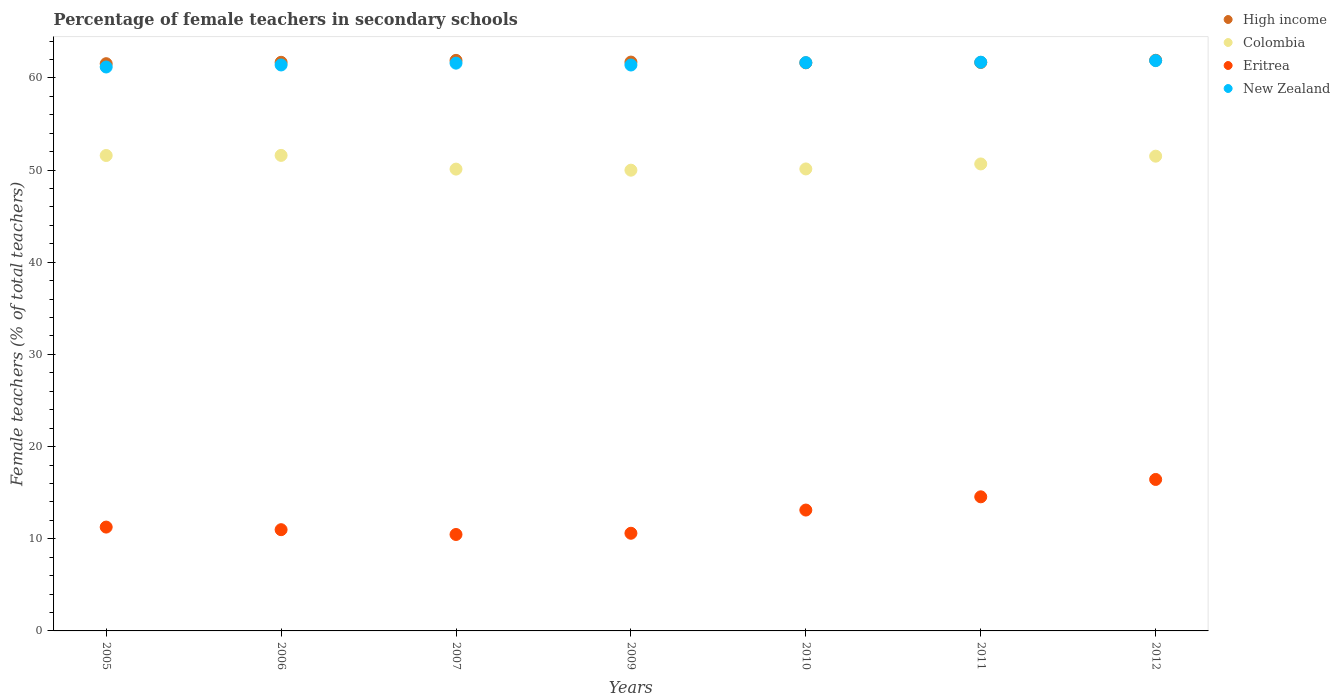How many different coloured dotlines are there?
Keep it short and to the point. 4. What is the percentage of female teachers in High income in 2005?
Give a very brief answer. 61.54. Across all years, what is the maximum percentage of female teachers in Eritrea?
Provide a short and direct response. 16.43. Across all years, what is the minimum percentage of female teachers in Eritrea?
Make the answer very short. 10.46. In which year was the percentage of female teachers in Colombia minimum?
Ensure brevity in your answer.  2009. What is the total percentage of female teachers in High income in the graph?
Offer a terse response. 432.08. What is the difference between the percentage of female teachers in Eritrea in 2009 and that in 2011?
Provide a short and direct response. -3.95. What is the difference between the percentage of female teachers in Eritrea in 2005 and the percentage of female teachers in New Zealand in 2007?
Your answer should be compact. -50.33. What is the average percentage of female teachers in High income per year?
Provide a short and direct response. 61.73. In the year 2009, what is the difference between the percentage of female teachers in Colombia and percentage of female teachers in Eritrea?
Ensure brevity in your answer.  39.39. What is the ratio of the percentage of female teachers in High income in 2006 to that in 2009?
Offer a terse response. 1. Is the difference between the percentage of female teachers in Colombia in 2006 and 2012 greater than the difference between the percentage of female teachers in Eritrea in 2006 and 2012?
Offer a very short reply. Yes. What is the difference between the highest and the second highest percentage of female teachers in New Zealand?
Make the answer very short. 0.17. What is the difference between the highest and the lowest percentage of female teachers in New Zealand?
Ensure brevity in your answer.  0.69. In how many years, is the percentage of female teachers in Eritrea greater than the average percentage of female teachers in Eritrea taken over all years?
Ensure brevity in your answer.  3. Is the percentage of female teachers in High income strictly greater than the percentage of female teachers in New Zealand over the years?
Keep it short and to the point. No. Is the percentage of female teachers in Eritrea strictly less than the percentage of female teachers in Colombia over the years?
Provide a succinct answer. Yes. Does the graph contain grids?
Make the answer very short. No. Where does the legend appear in the graph?
Your answer should be very brief. Top right. How are the legend labels stacked?
Ensure brevity in your answer.  Vertical. What is the title of the graph?
Provide a succinct answer. Percentage of female teachers in secondary schools. What is the label or title of the Y-axis?
Give a very brief answer. Female teachers (% of total teachers). What is the Female teachers (% of total teachers) in High income in 2005?
Make the answer very short. 61.54. What is the Female teachers (% of total teachers) of Colombia in 2005?
Provide a succinct answer. 51.58. What is the Female teachers (% of total teachers) in Eritrea in 2005?
Your answer should be compact. 11.27. What is the Female teachers (% of total teachers) in New Zealand in 2005?
Offer a very short reply. 61.18. What is the Female teachers (% of total teachers) in High income in 2006?
Your response must be concise. 61.69. What is the Female teachers (% of total teachers) in Colombia in 2006?
Your answer should be compact. 51.59. What is the Female teachers (% of total teachers) in Eritrea in 2006?
Provide a succinct answer. 10.98. What is the Female teachers (% of total teachers) in New Zealand in 2006?
Offer a very short reply. 61.4. What is the Female teachers (% of total teachers) in High income in 2007?
Make the answer very short. 61.9. What is the Female teachers (% of total teachers) of Colombia in 2007?
Your response must be concise. 50.11. What is the Female teachers (% of total teachers) in Eritrea in 2007?
Your answer should be compact. 10.46. What is the Female teachers (% of total teachers) in New Zealand in 2007?
Give a very brief answer. 61.6. What is the Female teachers (% of total teachers) of High income in 2009?
Keep it short and to the point. 61.72. What is the Female teachers (% of total teachers) in Colombia in 2009?
Offer a very short reply. 49.99. What is the Female teachers (% of total teachers) of Eritrea in 2009?
Offer a terse response. 10.6. What is the Female teachers (% of total teachers) of New Zealand in 2009?
Keep it short and to the point. 61.4. What is the Female teachers (% of total teachers) of High income in 2010?
Offer a terse response. 61.64. What is the Female teachers (% of total teachers) of Colombia in 2010?
Provide a short and direct response. 50.12. What is the Female teachers (% of total teachers) of Eritrea in 2010?
Provide a short and direct response. 13.11. What is the Female teachers (% of total teachers) in New Zealand in 2010?
Offer a terse response. 61.66. What is the Female teachers (% of total teachers) of High income in 2011?
Your response must be concise. 61.67. What is the Female teachers (% of total teachers) in Colombia in 2011?
Your answer should be very brief. 50.66. What is the Female teachers (% of total teachers) in Eritrea in 2011?
Keep it short and to the point. 14.55. What is the Female teachers (% of total teachers) of New Zealand in 2011?
Ensure brevity in your answer.  61.71. What is the Female teachers (% of total teachers) in High income in 2012?
Make the answer very short. 61.91. What is the Female teachers (% of total teachers) in Colombia in 2012?
Give a very brief answer. 51.51. What is the Female teachers (% of total teachers) of Eritrea in 2012?
Provide a short and direct response. 16.43. What is the Female teachers (% of total teachers) in New Zealand in 2012?
Offer a terse response. 61.88. Across all years, what is the maximum Female teachers (% of total teachers) in High income?
Your response must be concise. 61.91. Across all years, what is the maximum Female teachers (% of total teachers) in Colombia?
Make the answer very short. 51.59. Across all years, what is the maximum Female teachers (% of total teachers) in Eritrea?
Keep it short and to the point. 16.43. Across all years, what is the maximum Female teachers (% of total teachers) in New Zealand?
Provide a short and direct response. 61.88. Across all years, what is the minimum Female teachers (% of total teachers) of High income?
Give a very brief answer. 61.54. Across all years, what is the minimum Female teachers (% of total teachers) of Colombia?
Provide a succinct answer. 49.99. Across all years, what is the minimum Female teachers (% of total teachers) of Eritrea?
Give a very brief answer. 10.46. Across all years, what is the minimum Female teachers (% of total teachers) of New Zealand?
Keep it short and to the point. 61.18. What is the total Female teachers (% of total teachers) of High income in the graph?
Keep it short and to the point. 432.08. What is the total Female teachers (% of total teachers) in Colombia in the graph?
Give a very brief answer. 355.57. What is the total Female teachers (% of total teachers) of Eritrea in the graph?
Provide a short and direct response. 87.41. What is the total Female teachers (% of total teachers) of New Zealand in the graph?
Offer a very short reply. 430.83. What is the difference between the Female teachers (% of total teachers) of High income in 2005 and that in 2006?
Your answer should be compact. -0.15. What is the difference between the Female teachers (% of total teachers) in Colombia in 2005 and that in 2006?
Ensure brevity in your answer.  -0.01. What is the difference between the Female teachers (% of total teachers) of Eritrea in 2005 and that in 2006?
Your response must be concise. 0.28. What is the difference between the Female teachers (% of total teachers) of New Zealand in 2005 and that in 2006?
Keep it short and to the point. -0.22. What is the difference between the Female teachers (% of total teachers) in High income in 2005 and that in 2007?
Provide a succinct answer. -0.36. What is the difference between the Female teachers (% of total teachers) of Colombia in 2005 and that in 2007?
Your answer should be very brief. 1.48. What is the difference between the Female teachers (% of total teachers) in Eritrea in 2005 and that in 2007?
Offer a very short reply. 0.8. What is the difference between the Female teachers (% of total teachers) of New Zealand in 2005 and that in 2007?
Your answer should be very brief. -0.42. What is the difference between the Female teachers (% of total teachers) of High income in 2005 and that in 2009?
Make the answer very short. -0.17. What is the difference between the Female teachers (% of total teachers) in Colombia in 2005 and that in 2009?
Provide a short and direct response. 1.59. What is the difference between the Female teachers (% of total teachers) of Eritrea in 2005 and that in 2009?
Give a very brief answer. 0.67. What is the difference between the Female teachers (% of total teachers) in New Zealand in 2005 and that in 2009?
Your answer should be very brief. -0.22. What is the difference between the Female teachers (% of total teachers) of High income in 2005 and that in 2010?
Keep it short and to the point. -0.1. What is the difference between the Female teachers (% of total teachers) in Colombia in 2005 and that in 2010?
Your answer should be compact. 1.46. What is the difference between the Female teachers (% of total teachers) of Eritrea in 2005 and that in 2010?
Give a very brief answer. -1.85. What is the difference between the Female teachers (% of total teachers) of New Zealand in 2005 and that in 2010?
Make the answer very short. -0.47. What is the difference between the Female teachers (% of total teachers) of High income in 2005 and that in 2011?
Your answer should be very brief. -0.13. What is the difference between the Female teachers (% of total teachers) in Colombia in 2005 and that in 2011?
Offer a terse response. 0.92. What is the difference between the Female teachers (% of total teachers) in Eritrea in 2005 and that in 2011?
Provide a succinct answer. -3.28. What is the difference between the Female teachers (% of total teachers) of New Zealand in 2005 and that in 2011?
Your answer should be compact. -0.52. What is the difference between the Female teachers (% of total teachers) in High income in 2005 and that in 2012?
Offer a terse response. -0.37. What is the difference between the Female teachers (% of total teachers) of Colombia in 2005 and that in 2012?
Offer a terse response. 0.07. What is the difference between the Female teachers (% of total teachers) in Eritrea in 2005 and that in 2012?
Offer a terse response. -5.17. What is the difference between the Female teachers (% of total teachers) in New Zealand in 2005 and that in 2012?
Your answer should be compact. -0.69. What is the difference between the Female teachers (% of total teachers) of High income in 2006 and that in 2007?
Keep it short and to the point. -0.21. What is the difference between the Female teachers (% of total teachers) of Colombia in 2006 and that in 2007?
Your response must be concise. 1.49. What is the difference between the Female teachers (% of total teachers) of Eritrea in 2006 and that in 2007?
Your answer should be compact. 0.52. What is the difference between the Female teachers (% of total teachers) of New Zealand in 2006 and that in 2007?
Ensure brevity in your answer.  -0.2. What is the difference between the Female teachers (% of total teachers) of High income in 2006 and that in 2009?
Your answer should be compact. -0.02. What is the difference between the Female teachers (% of total teachers) in Colombia in 2006 and that in 2009?
Keep it short and to the point. 1.6. What is the difference between the Female teachers (% of total teachers) in Eritrea in 2006 and that in 2009?
Provide a short and direct response. 0.39. What is the difference between the Female teachers (% of total teachers) of New Zealand in 2006 and that in 2009?
Provide a succinct answer. 0.01. What is the difference between the Female teachers (% of total teachers) of High income in 2006 and that in 2010?
Make the answer very short. 0.06. What is the difference between the Female teachers (% of total teachers) in Colombia in 2006 and that in 2010?
Provide a short and direct response. 1.47. What is the difference between the Female teachers (% of total teachers) of Eritrea in 2006 and that in 2010?
Your answer should be compact. -2.13. What is the difference between the Female teachers (% of total teachers) of New Zealand in 2006 and that in 2010?
Your response must be concise. -0.25. What is the difference between the Female teachers (% of total teachers) of Colombia in 2006 and that in 2011?
Your answer should be compact. 0.93. What is the difference between the Female teachers (% of total teachers) in Eritrea in 2006 and that in 2011?
Your answer should be very brief. -3.57. What is the difference between the Female teachers (% of total teachers) of New Zealand in 2006 and that in 2011?
Your answer should be compact. -0.3. What is the difference between the Female teachers (% of total teachers) of High income in 2006 and that in 2012?
Make the answer very short. -0.22. What is the difference between the Female teachers (% of total teachers) in Colombia in 2006 and that in 2012?
Provide a succinct answer. 0.08. What is the difference between the Female teachers (% of total teachers) in Eritrea in 2006 and that in 2012?
Your response must be concise. -5.45. What is the difference between the Female teachers (% of total teachers) in New Zealand in 2006 and that in 2012?
Keep it short and to the point. -0.47. What is the difference between the Female teachers (% of total teachers) in High income in 2007 and that in 2009?
Ensure brevity in your answer.  0.19. What is the difference between the Female teachers (% of total teachers) in Colombia in 2007 and that in 2009?
Offer a terse response. 0.12. What is the difference between the Female teachers (% of total teachers) in Eritrea in 2007 and that in 2009?
Keep it short and to the point. -0.13. What is the difference between the Female teachers (% of total teachers) in New Zealand in 2007 and that in 2009?
Your response must be concise. 0.2. What is the difference between the Female teachers (% of total teachers) in High income in 2007 and that in 2010?
Provide a succinct answer. 0.27. What is the difference between the Female teachers (% of total teachers) in Colombia in 2007 and that in 2010?
Offer a terse response. -0.02. What is the difference between the Female teachers (% of total teachers) of Eritrea in 2007 and that in 2010?
Provide a short and direct response. -2.65. What is the difference between the Female teachers (% of total teachers) of New Zealand in 2007 and that in 2010?
Provide a short and direct response. -0.06. What is the difference between the Female teachers (% of total teachers) in High income in 2007 and that in 2011?
Provide a short and direct response. 0.23. What is the difference between the Female teachers (% of total teachers) in Colombia in 2007 and that in 2011?
Provide a succinct answer. -0.56. What is the difference between the Female teachers (% of total teachers) of Eritrea in 2007 and that in 2011?
Offer a terse response. -4.09. What is the difference between the Female teachers (% of total teachers) of New Zealand in 2007 and that in 2011?
Make the answer very short. -0.1. What is the difference between the Female teachers (% of total teachers) in High income in 2007 and that in 2012?
Provide a short and direct response. -0.01. What is the difference between the Female teachers (% of total teachers) of Colombia in 2007 and that in 2012?
Offer a terse response. -1.4. What is the difference between the Female teachers (% of total teachers) in Eritrea in 2007 and that in 2012?
Your response must be concise. -5.97. What is the difference between the Female teachers (% of total teachers) in New Zealand in 2007 and that in 2012?
Your response must be concise. -0.27. What is the difference between the Female teachers (% of total teachers) in High income in 2009 and that in 2010?
Give a very brief answer. 0.08. What is the difference between the Female teachers (% of total teachers) of Colombia in 2009 and that in 2010?
Your response must be concise. -0.13. What is the difference between the Female teachers (% of total teachers) of Eritrea in 2009 and that in 2010?
Your response must be concise. -2.52. What is the difference between the Female teachers (% of total teachers) in New Zealand in 2009 and that in 2010?
Provide a succinct answer. -0.26. What is the difference between the Female teachers (% of total teachers) in High income in 2009 and that in 2011?
Your answer should be compact. 0.04. What is the difference between the Female teachers (% of total teachers) of Colombia in 2009 and that in 2011?
Offer a very short reply. -0.68. What is the difference between the Female teachers (% of total teachers) in Eritrea in 2009 and that in 2011?
Keep it short and to the point. -3.95. What is the difference between the Female teachers (% of total teachers) of New Zealand in 2009 and that in 2011?
Ensure brevity in your answer.  -0.31. What is the difference between the Female teachers (% of total teachers) of High income in 2009 and that in 2012?
Provide a short and direct response. -0.2. What is the difference between the Female teachers (% of total teachers) in Colombia in 2009 and that in 2012?
Provide a succinct answer. -1.52. What is the difference between the Female teachers (% of total teachers) in Eritrea in 2009 and that in 2012?
Provide a short and direct response. -5.84. What is the difference between the Female teachers (% of total teachers) of New Zealand in 2009 and that in 2012?
Keep it short and to the point. -0.48. What is the difference between the Female teachers (% of total teachers) in High income in 2010 and that in 2011?
Offer a very short reply. -0.04. What is the difference between the Female teachers (% of total teachers) in Colombia in 2010 and that in 2011?
Offer a terse response. -0.54. What is the difference between the Female teachers (% of total teachers) of Eritrea in 2010 and that in 2011?
Provide a short and direct response. -1.44. What is the difference between the Female teachers (% of total teachers) in New Zealand in 2010 and that in 2011?
Give a very brief answer. -0.05. What is the difference between the Female teachers (% of total teachers) of High income in 2010 and that in 2012?
Keep it short and to the point. -0.27. What is the difference between the Female teachers (% of total teachers) of Colombia in 2010 and that in 2012?
Give a very brief answer. -1.39. What is the difference between the Female teachers (% of total teachers) in Eritrea in 2010 and that in 2012?
Keep it short and to the point. -3.32. What is the difference between the Female teachers (% of total teachers) in New Zealand in 2010 and that in 2012?
Your response must be concise. -0.22. What is the difference between the Female teachers (% of total teachers) of High income in 2011 and that in 2012?
Keep it short and to the point. -0.24. What is the difference between the Female teachers (% of total teachers) in Colombia in 2011 and that in 2012?
Make the answer very short. -0.84. What is the difference between the Female teachers (% of total teachers) of Eritrea in 2011 and that in 2012?
Keep it short and to the point. -1.88. What is the difference between the Female teachers (% of total teachers) in New Zealand in 2011 and that in 2012?
Your answer should be very brief. -0.17. What is the difference between the Female teachers (% of total teachers) of High income in 2005 and the Female teachers (% of total teachers) of Colombia in 2006?
Provide a succinct answer. 9.95. What is the difference between the Female teachers (% of total teachers) in High income in 2005 and the Female teachers (% of total teachers) in Eritrea in 2006?
Ensure brevity in your answer.  50.56. What is the difference between the Female teachers (% of total teachers) of High income in 2005 and the Female teachers (% of total teachers) of New Zealand in 2006?
Your response must be concise. 0.14. What is the difference between the Female teachers (% of total teachers) in Colombia in 2005 and the Female teachers (% of total teachers) in Eritrea in 2006?
Offer a very short reply. 40.6. What is the difference between the Female teachers (% of total teachers) of Colombia in 2005 and the Female teachers (% of total teachers) of New Zealand in 2006?
Ensure brevity in your answer.  -9.82. What is the difference between the Female teachers (% of total teachers) of Eritrea in 2005 and the Female teachers (% of total teachers) of New Zealand in 2006?
Offer a terse response. -50.14. What is the difference between the Female teachers (% of total teachers) of High income in 2005 and the Female teachers (% of total teachers) of Colombia in 2007?
Provide a succinct answer. 11.44. What is the difference between the Female teachers (% of total teachers) in High income in 2005 and the Female teachers (% of total teachers) in Eritrea in 2007?
Provide a short and direct response. 51.08. What is the difference between the Female teachers (% of total teachers) in High income in 2005 and the Female teachers (% of total teachers) in New Zealand in 2007?
Your response must be concise. -0.06. What is the difference between the Female teachers (% of total teachers) in Colombia in 2005 and the Female teachers (% of total teachers) in Eritrea in 2007?
Make the answer very short. 41.12. What is the difference between the Female teachers (% of total teachers) in Colombia in 2005 and the Female teachers (% of total teachers) in New Zealand in 2007?
Give a very brief answer. -10.02. What is the difference between the Female teachers (% of total teachers) in Eritrea in 2005 and the Female teachers (% of total teachers) in New Zealand in 2007?
Make the answer very short. -50.34. What is the difference between the Female teachers (% of total teachers) in High income in 2005 and the Female teachers (% of total teachers) in Colombia in 2009?
Provide a succinct answer. 11.55. What is the difference between the Female teachers (% of total teachers) of High income in 2005 and the Female teachers (% of total teachers) of Eritrea in 2009?
Make the answer very short. 50.95. What is the difference between the Female teachers (% of total teachers) of High income in 2005 and the Female teachers (% of total teachers) of New Zealand in 2009?
Offer a terse response. 0.14. What is the difference between the Female teachers (% of total teachers) of Colombia in 2005 and the Female teachers (% of total teachers) of Eritrea in 2009?
Ensure brevity in your answer.  40.99. What is the difference between the Female teachers (% of total teachers) in Colombia in 2005 and the Female teachers (% of total teachers) in New Zealand in 2009?
Offer a terse response. -9.82. What is the difference between the Female teachers (% of total teachers) of Eritrea in 2005 and the Female teachers (% of total teachers) of New Zealand in 2009?
Provide a succinct answer. -50.13. What is the difference between the Female teachers (% of total teachers) of High income in 2005 and the Female teachers (% of total teachers) of Colombia in 2010?
Offer a terse response. 11.42. What is the difference between the Female teachers (% of total teachers) of High income in 2005 and the Female teachers (% of total teachers) of Eritrea in 2010?
Keep it short and to the point. 48.43. What is the difference between the Female teachers (% of total teachers) of High income in 2005 and the Female teachers (% of total teachers) of New Zealand in 2010?
Provide a short and direct response. -0.12. What is the difference between the Female teachers (% of total teachers) of Colombia in 2005 and the Female teachers (% of total teachers) of Eritrea in 2010?
Offer a terse response. 38.47. What is the difference between the Female teachers (% of total teachers) of Colombia in 2005 and the Female teachers (% of total teachers) of New Zealand in 2010?
Provide a short and direct response. -10.08. What is the difference between the Female teachers (% of total teachers) in Eritrea in 2005 and the Female teachers (% of total teachers) in New Zealand in 2010?
Give a very brief answer. -50.39. What is the difference between the Female teachers (% of total teachers) in High income in 2005 and the Female teachers (% of total teachers) in Colombia in 2011?
Offer a terse response. 10.88. What is the difference between the Female teachers (% of total teachers) in High income in 2005 and the Female teachers (% of total teachers) in Eritrea in 2011?
Offer a very short reply. 46.99. What is the difference between the Female teachers (% of total teachers) in High income in 2005 and the Female teachers (% of total teachers) in New Zealand in 2011?
Your answer should be very brief. -0.16. What is the difference between the Female teachers (% of total teachers) of Colombia in 2005 and the Female teachers (% of total teachers) of Eritrea in 2011?
Ensure brevity in your answer.  37.03. What is the difference between the Female teachers (% of total teachers) in Colombia in 2005 and the Female teachers (% of total teachers) in New Zealand in 2011?
Your response must be concise. -10.12. What is the difference between the Female teachers (% of total teachers) of Eritrea in 2005 and the Female teachers (% of total teachers) of New Zealand in 2011?
Ensure brevity in your answer.  -50.44. What is the difference between the Female teachers (% of total teachers) of High income in 2005 and the Female teachers (% of total teachers) of Colombia in 2012?
Your answer should be compact. 10.03. What is the difference between the Female teachers (% of total teachers) of High income in 2005 and the Female teachers (% of total teachers) of Eritrea in 2012?
Ensure brevity in your answer.  45.11. What is the difference between the Female teachers (% of total teachers) of High income in 2005 and the Female teachers (% of total teachers) of New Zealand in 2012?
Make the answer very short. -0.33. What is the difference between the Female teachers (% of total teachers) of Colombia in 2005 and the Female teachers (% of total teachers) of Eritrea in 2012?
Ensure brevity in your answer.  35.15. What is the difference between the Female teachers (% of total teachers) in Colombia in 2005 and the Female teachers (% of total teachers) in New Zealand in 2012?
Your response must be concise. -10.29. What is the difference between the Female teachers (% of total teachers) in Eritrea in 2005 and the Female teachers (% of total teachers) in New Zealand in 2012?
Give a very brief answer. -50.61. What is the difference between the Female teachers (% of total teachers) in High income in 2006 and the Female teachers (% of total teachers) in Colombia in 2007?
Keep it short and to the point. 11.59. What is the difference between the Female teachers (% of total teachers) in High income in 2006 and the Female teachers (% of total teachers) in Eritrea in 2007?
Offer a terse response. 51.23. What is the difference between the Female teachers (% of total teachers) in High income in 2006 and the Female teachers (% of total teachers) in New Zealand in 2007?
Offer a terse response. 0.09. What is the difference between the Female teachers (% of total teachers) in Colombia in 2006 and the Female teachers (% of total teachers) in Eritrea in 2007?
Ensure brevity in your answer.  41.13. What is the difference between the Female teachers (% of total teachers) in Colombia in 2006 and the Female teachers (% of total teachers) in New Zealand in 2007?
Your answer should be very brief. -10.01. What is the difference between the Female teachers (% of total teachers) of Eritrea in 2006 and the Female teachers (% of total teachers) of New Zealand in 2007?
Your answer should be compact. -50.62. What is the difference between the Female teachers (% of total teachers) in High income in 2006 and the Female teachers (% of total teachers) in Colombia in 2009?
Give a very brief answer. 11.71. What is the difference between the Female teachers (% of total teachers) in High income in 2006 and the Female teachers (% of total teachers) in Eritrea in 2009?
Offer a very short reply. 51.1. What is the difference between the Female teachers (% of total teachers) in High income in 2006 and the Female teachers (% of total teachers) in New Zealand in 2009?
Offer a terse response. 0.29. What is the difference between the Female teachers (% of total teachers) in Colombia in 2006 and the Female teachers (% of total teachers) in Eritrea in 2009?
Provide a succinct answer. 41. What is the difference between the Female teachers (% of total teachers) of Colombia in 2006 and the Female teachers (% of total teachers) of New Zealand in 2009?
Give a very brief answer. -9.81. What is the difference between the Female teachers (% of total teachers) of Eritrea in 2006 and the Female teachers (% of total teachers) of New Zealand in 2009?
Give a very brief answer. -50.42. What is the difference between the Female teachers (% of total teachers) of High income in 2006 and the Female teachers (% of total teachers) of Colombia in 2010?
Give a very brief answer. 11.57. What is the difference between the Female teachers (% of total teachers) of High income in 2006 and the Female teachers (% of total teachers) of Eritrea in 2010?
Offer a very short reply. 48.58. What is the difference between the Female teachers (% of total teachers) of High income in 2006 and the Female teachers (% of total teachers) of New Zealand in 2010?
Offer a terse response. 0.04. What is the difference between the Female teachers (% of total teachers) in Colombia in 2006 and the Female teachers (% of total teachers) in Eritrea in 2010?
Ensure brevity in your answer.  38.48. What is the difference between the Female teachers (% of total teachers) in Colombia in 2006 and the Female teachers (% of total teachers) in New Zealand in 2010?
Make the answer very short. -10.07. What is the difference between the Female teachers (% of total teachers) in Eritrea in 2006 and the Female teachers (% of total teachers) in New Zealand in 2010?
Give a very brief answer. -50.67. What is the difference between the Female teachers (% of total teachers) of High income in 2006 and the Female teachers (% of total teachers) of Colombia in 2011?
Your response must be concise. 11.03. What is the difference between the Female teachers (% of total teachers) of High income in 2006 and the Female teachers (% of total teachers) of Eritrea in 2011?
Provide a short and direct response. 47.14. What is the difference between the Female teachers (% of total teachers) of High income in 2006 and the Female teachers (% of total teachers) of New Zealand in 2011?
Your response must be concise. -0.01. What is the difference between the Female teachers (% of total teachers) of Colombia in 2006 and the Female teachers (% of total teachers) of Eritrea in 2011?
Your answer should be compact. 37.04. What is the difference between the Female teachers (% of total teachers) of Colombia in 2006 and the Female teachers (% of total teachers) of New Zealand in 2011?
Keep it short and to the point. -10.11. What is the difference between the Female teachers (% of total teachers) in Eritrea in 2006 and the Female teachers (% of total teachers) in New Zealand in 2011?
Give a very brief answer. -50.72. What is the difference between the Female teachers (% of total teachers) in High income in 2006 and the Female teachers (% of total teachers) in Colombia in 2012?
Your answer should be compact. 10.18. What is the difference between the Female teachers (% of total teachers) of High income in 2006 and the Female teachers (% of total teachers) of Eritrea in 2012?
Your answer should be very brief. 45.26. What is the difference between the Female teachers (% of total teachers) of High income in 2006 and the Female teachers (% of total teachers) of New Zealand in 2012?
Your response must be concise. -0.18. What is the difference between the Female teachers (% of total teachers) in Colombia in 2006 and the Female teachers (% of total teachers) in Eritrea in 2012?
Your answer should be very brief. 35.16. What is the difference between the Female teachers (% of total teachers) of Colombia in 2006 and the Female teachers (% of total teachers) of New Zealand in 2012?
Your answer should be very brief. -10.28. What is the difference between the Female teachers (% of total teachers) of Eritrea in 2006 and the Female teachers (% of total teachers) of New Zealand in 2012?
Your answer should be very brief. -50.89. What is the difference between the Female teachers (% of total teachers) of High income in 2007 and the Female teachers (% of total teachers) of Colombia in 2009?
Keep it short and to the point. 11.91. What is the difference between the Female teachers (% of total teachers) of High income in 2007 and the Female teachers (% of total teachers) of Eritrea in 2009?
Ensure brevity in your answer.  51.31. What is the difference between the Female teachers (% of total teachers) in High income in 2007 and the Female teachers (% of total teachers) in New Zealand in 2009?
Your response must be concise. 0.5. What is the difference between the Female teachers (% of total teachers) in Colombia in 2007 and the Female teachers (% of total teachers) in Eritrea in 2009?
Your answer should be compact. 39.51. What is the difference between the Female teachers (% of total teachers) in Colombia in 2007 and the Female teachers (% of total teachers) in New Zealand in 2009?
Offer a terse response. -11.29. What is the difference between the Female teachers (% of total teachers) of Eritrea in 2007 and the Female teachers (% of total teachers) of New Zealand in 2009?
Offer a terse response. -50.94. What is the difference between the Female teachers (% of total teachers) in High income in 2007 and the Female teachers (% of total teachers) in Colombia in 2010?
Your response must be concise. 11.78. What is the difference between the Female teachers (% of total teachers) of High income in 2007 and the Female teachers (% of total teachers) of Eritrea in 2010?
Offer a very short reply. 48.79. What is the difference between the Female teachers (% of total teachers) in High income in 2007 and the Female teachers (% of total teachers) in New Zealand in 2010?
Offer a very short reply. 0.24. What is the difference between the Female teachers (% of total teachers) of Colombia in 2007 and the Female teachers (% of total teachers) of Eritrea in 2010?
Give a very brief answer. 36.99. What is the difference between the Female teachers (% of total teachers) in Colombia in 2007 and the Female teachers (% of total teachers) in New Zealand in 2010?
Your answer should be very brief. -11.55. What is the difference between the Female teachers (% of total teachers) in Eritrea in 2007 and the Female teachers (% of total teachers) in New Zealand in 2010?
Your response must be concise. -51.2. What is the difference between the Female teachers (% of total teachers) in High income in 2007 and the Female teachers (% of total teachers) in Colombia in 2011?
Offer a very short reply. 11.24. What is the difference between the Female teachers (% of total teachers) of High income in 2007 and the Female teachers (% of total teachers) of Eritrea in 2011?
Your answer should be very brief. 47.35. What is the difference between the Female teachers (% of total teachers) in High income in 2007 and the Female teachers (% of total teachers) in New Zealand in 2011?
Your answer should be compact. 0.2. What is the difference between the Female teachers (% of total teachers) in Colombia in 2007 and the Female teachers (% of total teachers) in Eritrea in 2011?
Make the answer very short. 35.56. What is the difference between the Female teachers (% of total teachers) of Colombia in 2007 and the Female teachers (% of total teachers) of New Zealand in 2011?
Provide a succinct answer. -11.6. What is the difference between the Female teachers (% of total teachers) in Eritrea in 2007 and the Female teachers (% of total teachers) in New Zealand in 2011?
Offer a very short reply. -51.24. What is the difference between the Female teachers (% of total teachers) of High income in 2007 and the Female teachers (% of total teachers) of Colombia in 2012?
Make the answer very short. 10.39. What is the difference between the Female teachers (% of total teachers) in High income in 2007 and the Female teachers (% of total teachers) in Eritrea in 2012?
Offer a very short reply. 45.47. What is the difference between the Female teachers (% of total teachers) in High income in 2007 and the Female teachers (% of total teachers) in New Zealand in 2012?
Make the answer very short. 0.03. What is the difference between the Female teachers (% of total teachers) of Colombia in 2007 and the Female teachers (% of total teachers) of Eritrea in 2012?
Provide a succinct answer. 33.67. What is the difference between the Female teachers (% of total teachers) of Colombia in 2007 and the Female teachers (% of total teachers) of New Zealand in 2012?
Your answer should be very brief. -11.77. What is the difference between the Female teachers (% of total teachers) in Eritrea in 2007 and the Female teachers (% of total teachers) in New Zealand in 2012?
Make the answer very short. -51.41. What is the difference between the Female teachers (% of total teachers) of High income in 2009 and the Female teachers (% of total teachers) of Colombia in 2010?
Provide a succinct answer. 11.59. What is the difference between the Female teachers (% of total teachers) in High income in 2009 and the Female teachers (% of total teachers) in Eritrea in 2010?
Keep it short and to the point. 48.6. What is the difference between the Female teachers (% of total teachers) of High income in 2009 and the Female teachers (% of total teachers) of New Zealand in 2010?
Provide a succinct answer. 0.06. What is the difference between the Female teachers (% of total teachers) of Colombia in 2009 and the Female teachers (% of total teachers) of Eritrea in 2010?
Offer a very short reply. 36.87. What is the difference between the Female teachers (% of total teachers) in Colombia in 2009 and the Female teachers (% of total teachers) in New Zealand in 2010?
Ensure brevity in your answer.  -11.67. What is the difference between the Female teachers (% of total teachers) in Eritrea in 2009 and the Female teachers (% of total teachers) in New Zealand in 2010?
Keep it short and to the point. -51.06. What is the difference between the Female teachers (% of total teachers) in High income in 2009 and the Female teachers (% of total teachers) in Colombia in 2011?
Your response must be concise. 11.05. What is the difference between the Female teachers (% of total teachers) in High income in 2009 and the Female teachers (% of total teachers) in Eritrea in 2011?
Keep it short and to the point. 47.17. What is the difference between the Female teachers (% of total teachers) in High income in 2009 and the Female teachers (% of total teachers) in New Zealand in 2011?
Provide a succinct answer. 0.01. What is the difference between the Female teachers (% of total teachers) of Colombia in 2009 and the Female teachers (% of total teachers) of Eritrea in 2011?
Your response must be concise. 35.44. What is the difference between the Female teachers (% of total teachers) in Colombia in 2009 and the Female teachers (% of total teachers) in New Zealand in 2011?
Offer a very short reply. -11.72. What is the difference between the Female teachers (% of total teachers) in Eritrea in 2009 and the Female teachers (% of total teachers) in New Zealand in 2011?
Your answer should be very brief. -51.11. What is the difference between the Female teachers (% of total teachers) of High income in 2009 and the Female teachers (% of total teachers) of Colombia in 2012?
Ensure brevity in your answer.  10.21. What is the difference between the Female teachers (% of total teachers) of High income in 2009 and the Female teachers (% of total teachers) of Eritrea in 2012?
Offer a terse response. 45.28. What is the difference between the Female teachers (% of total teachers) of High income in 2009 and the Female teachers (% of total teachers) of New Zealand in 2012?
Make the answer very short. -0.16. What is the difference between the Female teachers (% of total teachers) of Colombia in 2009 and the Female teachers (% of total teachers) of Eritrea in 2012?
Ensure brevity in your answer.  33.55. What is the difference between the Female teachers (% of total teachers) in Colombia in 2009 and the Female teachers (% of total teachers) in New Zealand in 2012?
Offer a very short reply. -11.89. What is the difference between the Female teachers (% of total teachers) in Eritrea in 2009 and the Female teachers (% of total teachers) in New Zealand in 2012?
Your answer should be compact. -51.28. What is the difference between the Female teachers (% of total teachers) of High income in 2010 and the Female teachers (% of total teachers) of Colombia in 2011?
Provide a succinct answer. 10.97. What is the difference between the Female teachers (% of total teachers) in High income in 2010 and the Female teachers (% of total teachers) in Eritrea in 2011?
Give a very brief answer. 47.09. What is the difference between the Female teachers (% of total teachers) of High income in 2010 and the Female teachers (% of total teachers) of New Zealand in 2011?
Your answer should be very brief. -0.07. What is the difference between the Female teachers (% of total teachers) of Colombia in 2010 and the Female teachers (% of total teachers) of Eritrea in 2011?
Your answer should be compact. 35.57. What is the difference between the Female teachers (% of total teachers) of Colombia in 2010 and the Female teachers (% of total teachers) of New Zealand in 2011?
Your response must be concise. -11.58. What is the difference between the Female teachers (% of total teachers) of Eritrea in 2010 and the Female teachers (% of total teachers) of New Zealand in 2011?
Offer a very short reply. -48.59. What is the difference between the Female teachers (% of total teachers) of High income in 2010 and the Female teachers (% of total teachers) of Colombia in 2012?
Provide a succinct answer. 10.13. What is the difference between the Female teachers (% of total teachers) of High income in 2010 and the Female teachers (% of total teachers) of Eritrea in 2012?
Offer a very short reply. 45.2. What is the difference between the Female teachers (% of total teachers) in High income in 2010 and the Female teachers (% of total teachers) in New Zealand in 2012?
Your answer should be compact. -0.24. What is the difference between the Female teachers (% of total teachers) in Colombia in 2010 and the Female teachers (% of total teachers) in Eritrea in 2012?
Offer a terse response. 33.69. What is the difference between the Female teachers (% of total teachers) of Colombia in 2010 and the Female teachers (% of total teachers) of New Zealand in 2012?
Offer a terse response. -11.75. What is the difference between the Female teachers (% of total teachers) in Eritrea in 2010 and the Female teachers (% of total teachers) in New Zealand in 2012?
Make the answer very short. -48.76. What is the difference between the Female teachers (% of total teachers) in High income in 2011 and the Female teachers (% of total teachers) in Colombia in 2012?
Provide a succinct answer. 10.16. What is the difference between the Female teachers (% of total teachers) of High income in 2011 and the Female teachers (% of total teachers) of Eritrea in 2012?
Ensure brevity in your answer.  45.24. What is the difference between the Female teachers (% of total teachers) of High income in 2011 and the Female teachers (% of total teachers) of New Zealand in 2012?
Ensure brevity in your answer.  -0.2. What is the difference between the Female teachers (% of total teachers) of Colombia in 2011 and the Female teachers (% of total teachers) of Eritrea in 2012?
Keep it short and to the point. 34.23. What is the difference between the Female teachers (% of total teachers) of Colombia in 2011 and the Female teachers (% of total teachers) of New Zealand in 2012?
Keep it short and to the point. -11.21. What is the difference between the Female teachers (% of total teachers) in Eritrea in 2011 and the Female teachers (% of total teachers) in New Zealand in 2012?
Provide a short and direct response. -47.33. What is the average Female teachers (% of total teachers) of High income per year?
Keep it short and to the point. 61.73. What is the average Female teachers (% of total teachers) in Colombia per year?
Provide a succinct answer. 50.8. What is the average Female teachers (% of total teachers) of Eritrea per year?
Offer a very short reply. 12.49. What is the average Female teachers (% of total teachers) in New Zealand per year?
Give a very brief answer. 61.55. In the year 2005, what is the difference between the Female teachers (% of total teachers) in High income and Female teachers (% of total teachers) in Colombia?
Your answer should be very brief. 9.96. In the year 2005, what is the difference between the Female teachers (% of total teachers) of High income and Female teachers (% of total teachers) of Eritrea?
Give a very brief answer. 50.28. In the year 2005, what is the difference between the Female teachers (% of total teachers) in High income and Female teachers (% of total teachers) in New Zealand?
Your answer should be very brief. 0.36. In the year 2005, what is the difference between the Female teachers (% of total teachers) of Colombia and Female teachers (% of total teachers) of Eritrea?
Give a very brief answer. 40.32. In the year 2005, what is the difference between the Female teachers (% of total teachers) in Colombia and Female teachers (% of total teachers) in New Zealand?
Give a very brief answer. -9.6. In the year 2005, what is the difference between the Female teachers (% of total teachers) in Eritrea and Female teachers (% of total teachers) in New Zealand?
Ensure brevity in your answer.  -49.92. In the year 2006, what is the difference between the Female teachers (% of total teachers) of High income and Female teachers (% of total teachers) of Colombia?
Keep it short and to the point. 10.1. In the year 2006, what is the difference between the Female teachers (% of total teachers) in High income and Female teachers (% of total teachers) in Eritrea?
Your answer should be very brief. 50.71. In the year 2006, what is the difference between the Female teachers (% of total teachers) in High income and Female teachers (% of total teachers) in New Zealand?
Make the answer very short. 0.29. In the year 2006, what is the difference between the Female teachers (% of total teachers) in Colombia and Female teachers (% of total teachers) in Eritrea?
Your answer should be very brief. 40.61. In the year 2006, what is the difference between the Female teachers (% of total teachers) in Colombia and Female teachers (% of total teachers) in New Zealand?
Provide a short and direct response. -9.81. In the year 2006, what is the difference between the Female teachers (% of total teachers) in Eritrea and Female teachers (% of total teachers) in New Zealand?
Your answer should be very brief. -50.42. In the year 2007, what is the difference between the Female teachers (% of total teachers) of High income and Female teachers (% of total teachers) of Colombia?
Offer a very short reply. 11.8. In the year 2007, what is the difference between the Female teachers (% of total teachers) in High income and Female teachers (% of total teachers) in Eritrea?
Offer a terse response. 51.44. In the year 2007, what is the difference between the Female teachers (% of total teachers) in High income and Female teachers (% of total teachers) in New Zealand?
Offer a very short reply. 0.3. In the year 2007, what is the difference between the Female teachers (% of total teachers) in Colombia and Female teachers (% of total teachers) in Eritrea?
Provide a short and direct response. 39.64. In the year 2007, what is the difference between the Female teachers (% of total teachers) in Colombia and Female teachers (% of total teachers) in New Zealand?
Make the answer very short. -11.5. In the year 2007, what is the difference between the Female teachers (% of total teachers) in Eritrea and Female teachers (% of total teachers) in New Zealand?
Keep it short and to the point. -51.14. In the year 2009, what is the difference between the Female teachers (% of total teachers) in High income and Female teachers (% of total teachers) in Colombia?
Provide a short and direct response. 11.73. In the year 2009, what is the difference between the Female teachers (% of total teachers) of High income and Female teachers (% of total teachers) of Eritrea?
Offer a very short reply. 51.12. In the year 2009, what is the difference between the Female teachers (% of total teachers) of High income and Female teachers (% of total teachers) of New Zealand?
Your answer should be very brief. 0.32. In the year 2009, what is the difference between the Female teachers (% of total teachers) in Colombia and Female teachers (% of total teachers) in Eritrea?
Offer a very short reply. 39.39. In the year 2009, what is the difference between the Female teachers (% of total teachers) of Colombia and Female teachers (% of total teachers) of New Zealand?
Give a very brief answer. -11.41. In the year 2009, what is the difference between the Female teachers (% of total teachers) of Eritrea and Female teachers (% of total teachers) of New Zealand?
Your answer should be compact. -50.8. In the year 2010, what is the difference between the Female teachers (% of total teachers) in High income and Female teachers (% of total teachers) in Colombia?
Your answer should be very brief. 11.51. In the year 2010, what is the difference between the Female teachers (% of total teachers) in High income and Female teachers (% of total teachers) in Eritrea?
Your answer should be very brief. 48.52. In the year 2010, what is the difference between the Female teachers (% of total teachers) in High income and Female teachers (% of total teachers) in New Zealand?
Your answer should be very brief. -0.02. In the year 2010, what is the difference between the Female teachers (% of total teachers) of Colombia and Female teachers (% of total teachers) of Eritrea?
Provide a succinct answer. 37.01. In the year 2010, what is the difference between the Female teachers (% of total teachers) of Colombia and Female teachers (% of total teachers) of New Zealand?
Your response must be concise. -11.54. In the year 2010, what is the difference between the Female teachers (% of total teachers) of Eritrea and Female teachers (% of total teachers) of New Zealand?
Your answer should be compact. -48.54. In the year 2011, what is the difference between the Female teachers (% of total teachers) of High income and Female teachers (% of total teachers) of Colombia?
Offer a terse response. 11.01. In the year 2011, what is the difference between the Female teachers (% of total teachers) of High income and Female teachers (% of total teachers) of Eritrea?
Your answer should be compact. 47.12. In the year 2011, what is the difference between the Female teachers (% of total teachers) in High income and Female teachers (% of total teachers) in New Zealand?
Your answer should be compact. -0.03. In the year 2011, what is the difference between the Female teachers (% of total teachers) in Colombia and Female teachers (% of total teachers) in Eritrea?
Your answer should be very brief. 36.12. In the year 2011, what is the difference between the Female teachers (% of total teachers) of Colombia and Female teachers (% of total teachers) of New Zealand?
Give a very brief answer. -11.04. In the year 2011, what is the difference between the Female teachers (% of total teachers) in Eritrea and Female teachers (% of total teachers) in New Zealand?
Your answer should be compact. -47.16. In the year 2012, what is the difference between the Female teachers (% of total teachers) of High income and Female teachers (% of total teachers) of Colombia?
Offer a terse response. 10.4. In the year 2012, what is the difference between the Female teachers (% of total teachers) in High income and Female teachers (% of total teachers) in Eritrea?
Offer a very short reply. 45.48. In the year 2012, what is the difference between the Female teachers (% of total teachers) in High income and Female teachers (% of total teachers) in New Zealand?
Offer a terse response. 0.04. In the year 2012, what is the difference between the Female teachers (% of total teachers) of Colombia and Female teachers (% of total teachers) of Eritrea?
Provide a short and direct response. 35.08. In the year 2012, what is the difference between the Female teachers (% of total teachers) in Colombia and Female teachers (% of total teachers) in New Zealand?
Your response must be concise. -10.37. In the year 2012, what is the difference between the Female teachers (% of total teachers) in Eritrea and Female teachers (% of total teachers) in New Zealand?
Provide a short and direct response. -45.44. What is the ratio of the Female teachers (% of total teachers) in High income in 2005 to that in 2006?
Make the answer very short. 1. What is the ratio of the Female teachers (% of total teachers) of Colombia in 2005 to that in 2006?
Make the answer very short. 1. What is the ratio of the Female teachers (% of total teachers) of Eritrea in 2005 to that in 2006?
Offer a very short reply. 1.03. What is the ratio of the Female teachers (% of total teachers) in New Zealand in 2005 to that in 2006?
Provide a short and direct response. 1. What is the ratio of the Female teachers (% of total teachers) in Colombia in 2005 to that in 2007?
Keep it short and to the point. 1.03. What is the ratio of the Female teachers (% of total teachers) in Eritrea in 2005 to that in 2007?
Your answer should be compact. 1.08. What is the ratio of the Female teachers (% of total teachers) in New Zealand in 2005 to that in 2007?
Give a very brief answer. 0.99. What is the ratio of the Female teachers (% of total teachers) of High income in 2005 to that in 2009?
Ensure brevity in your answer.  1. What is the ratio of the Female teachers (% of total teachers) of Colombia in 2005 to that in 2009?
Offer a terse response. 1.03. What is the ratio of the Female teachers (% of total teachers) of Eritrea in 2005 to that in 2009?
Offer a very short reply. 1.06. What is the ratio of the Female teachers (% of total teachers) of New Zealand in 2005 to that in 2009?
Ensure brevity in your answer.  1. What is the ratio of the Female teachers (% of total teachers) of High income in 2005 to that in 2010?
Ensure brevity in your answer.  1. What is the ratio of the Female teachers (% of total teachers) of Colombia in 2005 to that in 2010?
Keep it short and to the point. 1.03. What is the ratio of the Female teachers (% of total teachers) of Eritrea in 2005 to that in 2010?
Your answer should be compact. 0.86. What is the ratio of the Female teachers (% of total teachers) in New Zealand in 2005 to that in 2010?
Give a very brief answer. 0.99. What is the ratio of the Female teachers (% of total teachers) of High income in 2005 to that in 2011?
Keep it short and to the point. 1. What is the ratio of the Female teachers (% of total teachers) in Colombia in 2005 to that in 2011?
Your response must be concise. 1.02. What is the ratio of the Female teachers (% of total teachers) of Eritrea in 2005 to that in 2011?
Ensure brevity in your answer.  0.77. What is the ratio of the Female teachers (% of total teachers) in Colombia in 2005 to that in 2012?
Give a very brief answer. 1. What is the ratio of the Female teachers (% of total teachers) of Eritrea in 2005 to that in 2012?
Give a very brief answer. 0.69. What is the ratio of the Female teachers (% of total teachers) of New Zealand in 2005 to that in 2012?
Your response must be concise. 0.99. What is the ratio of the Female teachers (% of total teachers) of Colombia in 2006 to that in 2007?
Keep it short and to the point. 1.03. What is the ratio of the Female teachers (% of total teachers) in Eritrea in 2006 to that in 2007?
Your response must be concise. 1.05. What is the ratio of the Female teachers (% of total teachers) in New Zealand in 2006 to that in 2007?
Your answer should be very brief. 1. What is the ratio of the Female teachers (% of total teachers) in High income in 2006 to that in 2009?
Provide a succinct answer. 1. What is the ratio of the Female teachers (% of total teachers) in Colombia in 2006 to that in 2009?
Offer a terse response. 1.03. What is the ratio of the Female teachers (% of total teachers) in Eritrea in 2006 to that in 2009?
Your answer should be compact. 1.04. What is the ratio of the Female teachers (% of total teachers) in Colombia in 2006 to that in 2010?
Offer a terse response. 1.03. What is the ratio of the Female teachers (% of total teachers) in Eritrea in 2006 to that in 2010?
Ensure brevity in your answer.  0.84. What is the ratio of the Female teachers (% of total teachers) of High income in 2006 to that in 2011?
Offer a very short reply. 1. What is the ratio of the Female teachers (% of total teachers) of Colombia in 2006 to that in 2011?
Your answer should be compact. 1.02. What is the ratio of the Female teachers (% of total teachers) of Eritrea in 2006 to that in 2011?
Your response must be concise. 0.75. What is the ratio of the Female teachers (% of total teachers) in New Zealand in 2006 to that in 2011?
Offer a terse response. 1. What is the ratio of the Female teachers (% of total teachers) in High income in 2006 to that in 2012?
Your response must be concise. 1. What is the ratio of the Female teachers (% of total teachers) of Colombia in 2006 to that in 2012?
Keep it short and to the point. 1. What is the ratio of the Female teachers (% of total teachers) in Eritrea in 2006 to that in 2012?
Provide a succinct answer. 0.67. What is the ratio of the Female teachers (% of total teachers) in New Zealand in 2006 to that in 2012?
Give a very brief answer. 0.99. What is the ratio of the Female teachers (% of total teachers) of Colombia in 2007 to that in 2009?
Make the answer very short. 1. What is the ratio of the Female teachers (% of total teachers) in Eritrea in 2007 to that in 2009?
Your answer should be compact. 0.99. What is the ratio of the Female teachers (% of total teachers) of Colombia in 2007 to that in 2010?
Give a very brief answer. 1. What is the ratio of the Female teachers (% of total teachers) of Eritrea in 2007 to that in 2010?
Ensure brevity in your answer.  0.8. What is the ratio of the Female teachers (% of total teachers) in Eritrea in 2007 to that in 2011?
Provide a short and direct response. 0.72. What is the ratio of the Female teachers (% of total teachers) in New Zealand in 2007 to that in 2011?
Offer a terse response. 1. What is the ratio of the Female teachers (% of total teachers) in High income in 2007 to that in 2012?
Your answer should be very brief. 1. What is the ratio of the Female teachers (% of total teachers) in Colombia in 2007 to that in 2012?
Your answer should be very brief. 0.97. What is the ratio of the Female teachers (% of total teachers) of Eritrea in 2007 to that in 2012?
Your answer should be very brief. 0.64. What is the ratio of the Female teachers (% of total teachers) in High income in 2009 to that in 2010?
Offer a terse response. 1. What is the ratio of the Female teachers (% of total teachers) in Colombia in 2009 to that in 2010?
Make the answer very short. 1. What is the ratio of the Female teachers (% of total teachers) in Eritrea in 2009 to that in 2010?
Give a very brief answer. 0.81. What is the ratio of the Female teachers (% of total teachers) of High income in 2009 to that in 2011?
Your response must be concise. 1. What is the ratio of the Female teachers (% of total teachers) of Colombia in 2009 to that in 2011?
Provide a succinct answer. 0.99. What is the ratio of the Female teachers (% of total teachers) of Eritrea in 2009 to that in 2011?
Make the answer very short. 0.73. What is the ratio of the Female teachers (% of total teachers) of New Zealand in 2009 to that in 2011?
Offer a terse response. 0.99. What is the ratio of the Female teachers (% of total teachers) in High income in 2009 to that in 2012?
Give a very brief answer. 1. What is the ratio of the Female teachers (% of total teachers) of Colombia in 2009 to that in 2012?
Your answer should be compact. 0.97. What is the ratio of the Female teachers (% of total teachers) in Eritrea in 2009 to that in 2012?
Your answer should be compact. 0.64. What is the ratio of the Female teachers (% of total teachers) of New Zealand in 2009 to that in 2012?
Your response must be concise. 0.99. What is the ratio of the Female teachers (% of total teachers) of High income in 2010 to that in 2011?
Make the answer very short. 1. What is the ratio of the Female teachers (% of total teachers) in Colombia in 2010 to that in 2011?
Provide a short and direct response. 0.99. What is the ratio of the Female teachers (% of total teachers) of Eritrea in 2010 to that in 2011?
Provide a succinct answer. 0.9. What is the ratio of the Female teachers (% of total teachers) of New Zealand in 2010 to that in 2011?
Provide a short and direct response. 1. What is the ratio of the Female teachers (% of total teachers) of High income in 2010 to that in 2012?
Offer a terse response. 1. What is the ratio of the Female teachers (% of total teachers) in Colombia in 2010 to that in 2012?
Offer a very short reply. 0.97. What is the ratio of the Female teachers (% of total teachers) in Eritrea in 2010 to that in 2012?
Your answer should be very brief. 0.8. What is the ratio of the Female teachers (% of total teachers) in High income in 2011 to that in 2012?
Give a very brief answer. 1. What is the ratio of the Female teachers (% of total teachers) of Colombia in 2011 to that in 2012?
Offer a terse response. 0.98. What is the ratio of the Female teachers (% of total teachers) in Eritrea in 2011 to that in 2012?
Offer a very short reply. 0.89. What is the difference between the highest and the second highest Female teachers (% of total teachers) of High income?
Keep it short and to the point. 0.01. What is the difference between the highest and the second highest Female teachers (% of total teachers) of Colombia?
Your answer should be very brief. 0.01. What is the difference between the highest and the second highest Female teachers (% of total teachers) of Eritrea?
Your answer should be very brief. 1.88. What is the difference between the highest and the second highest Female teachers (% of total teachers) in New Zealand?
Your response must be concise. 0.17. What is the difference between the highest and the lowest Female teachers (% of total teachers) of High income?
Your answer should be compact. 0.37. What is the difference between the highest and the lowest Female teachers (% of total teachers) in Colombia?
Make the answer very short. 1.6. What is the difference between the highest and the lowest Female teachers (% of total teachers) of Eritrea?
Offer a terse response. 5.97. What is the difference between the highest and the lowest Female teachers (% of total teachers) of New Zealand?
Your answer should be compact. 0.69. 